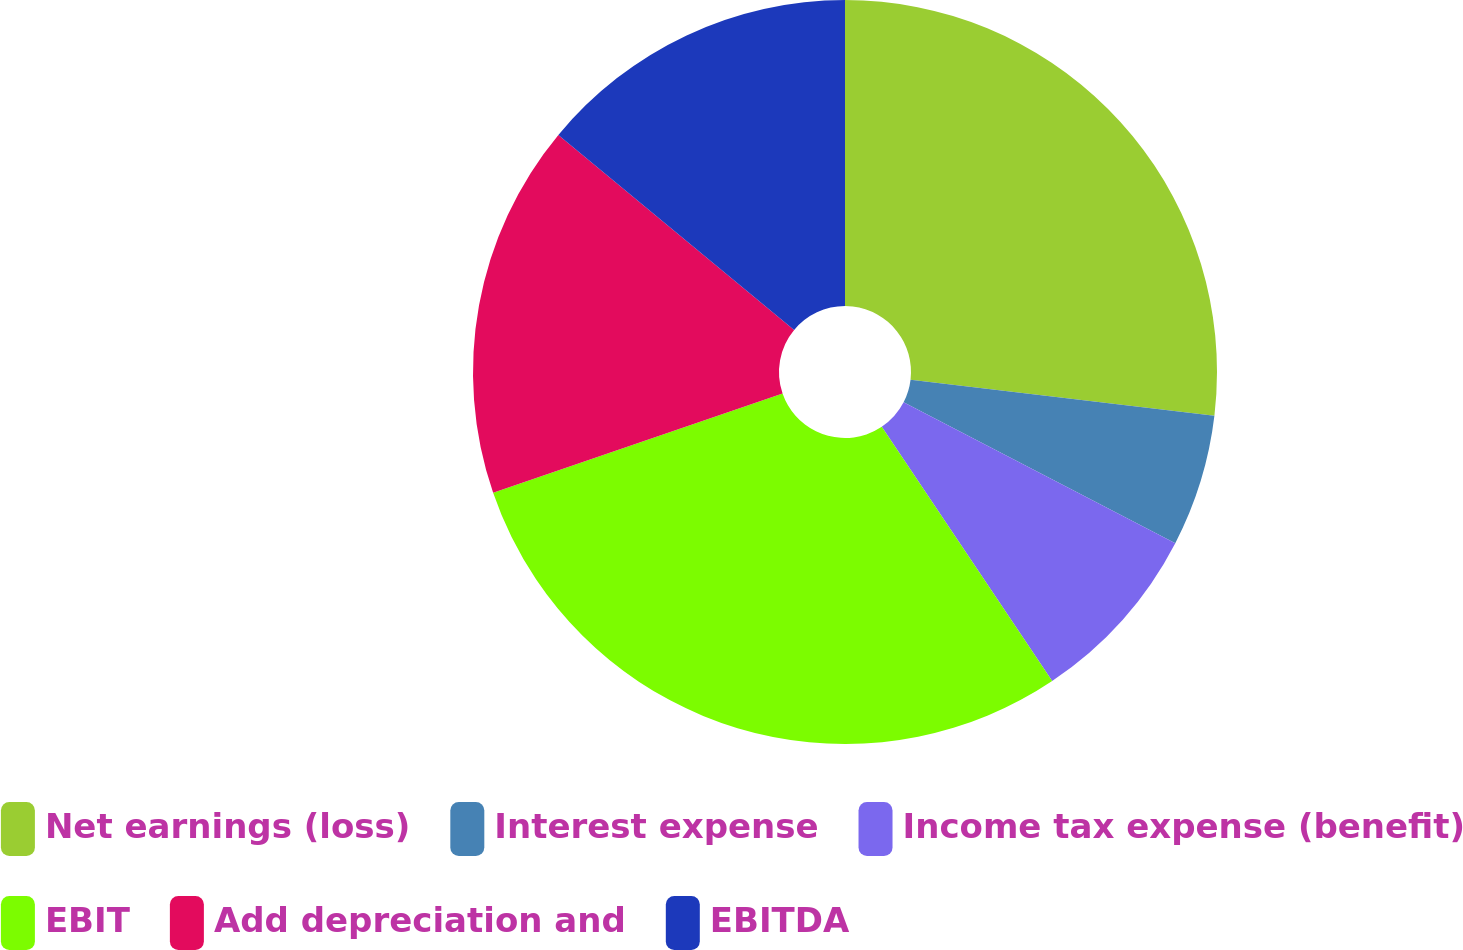<chart> <loc_0><loc_0><loc_500><loc_500><pie_chart><fcel>Net earnings (loss)<fcel>Interest expense<fcel>Income tax expense (benefit)<fcel>EBIT<fcel>Add depreciation and<fcel>EBITDA<nl><fcel>26.88%<fcel>5.73%<fcel>7.99%<fcel>29.14%<fcel>16.26%<fcel>14.0%<nl></chart> 